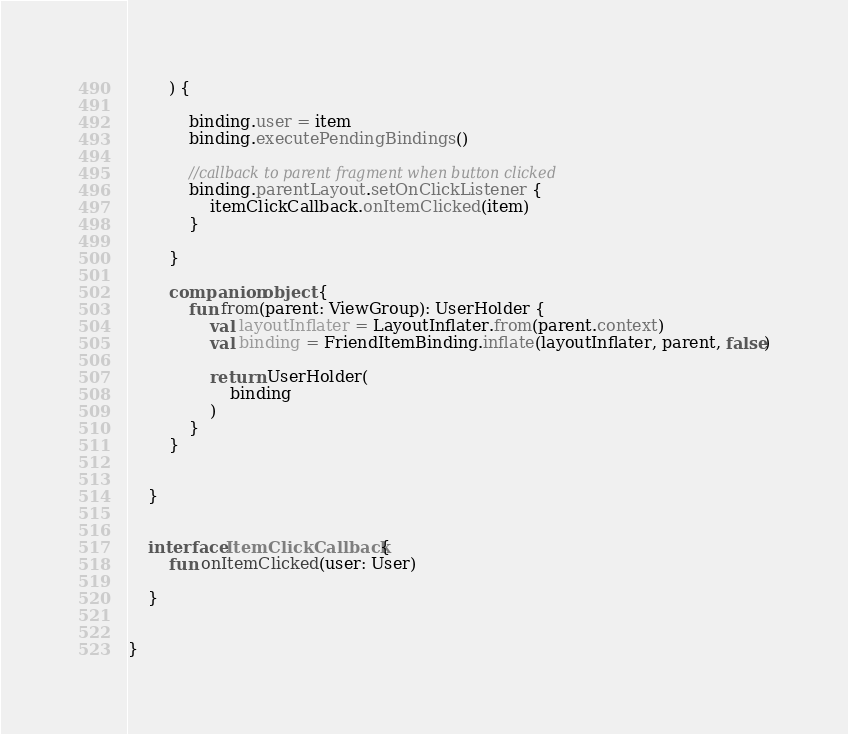Convert code to text. <code><loc_0><loc_0><loc_500><loc_500><_Kotlin_>        ) {

            binding.user = item
            binding.executePendingBindings()

            //callback to parent fragment when button clicked
            binding.parentLayout.setOnClickListener {
                itemClickCallback.onItemClicked(item)
            }

        }

        companion object {
            fun from(parent: ViewGroup): UserHolder {
                val layoutInflater = LayoutInflater.from(parent.context)
                val binding = FriendItemBinding.inflate(layoutInflater, parent, false)

                return UserHolder(
                    binding
                )
            }
        }


    }


    interface ItemClickCallback {
        fun onItemClicked(user: User)

    }


}


</code> 